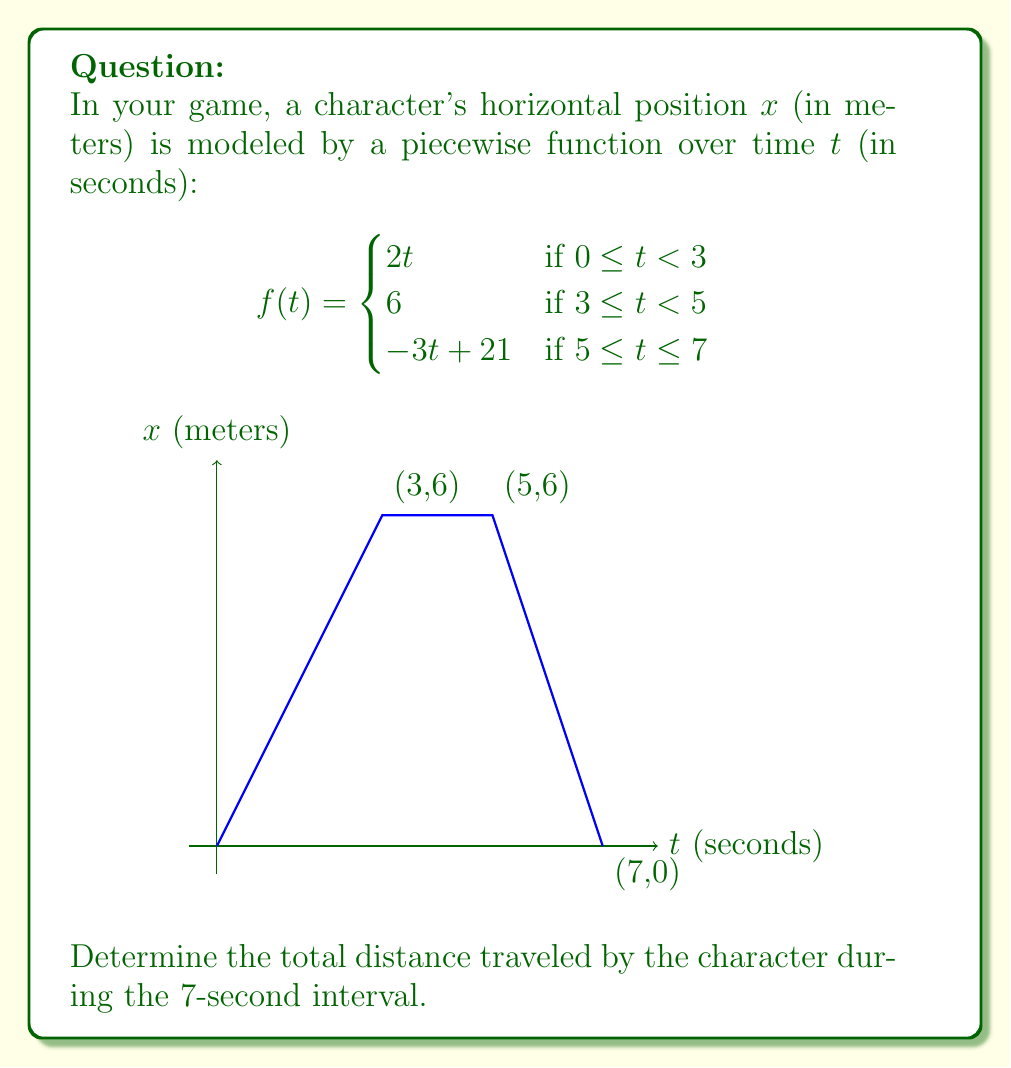Could you help me with this problem? Let's break this down step-by-step:

1) First, we need to understand what each piece of the function represents:
   - From 0 to 3 seconds, the character moves at a constant speed of 2 m/s.
   - From 3 to 5 seconds, the character stays still at x = 6 m.
   - From 5 to 7 seconds, the character moves backwards at a speed of 3 m/s.

2) Let's calculate the distance for each interval:

   a) 0 ≤ t < 3:
      Distance = f(3) - f(0) = 2(3) - 2(0) = 6 m

   b) 3 ≤ t < 5:
      The character doesn't move, so distance = 0 m

   c) 5 ≤ t ≤ 7:
      Distance = |f(7) - f(5)| = |(-3(7) + 21) - 6| = |0 - 6| = 6 m
      We use absolute value because we're interested in the distance, not displacement.

3) Total distance is the sum of these distances:
   Total distance = 6 + 0 + 6 = 12 m

Therefore, the character travels a total of 12 meters during the 7-second interval.
Answer: 12 m 